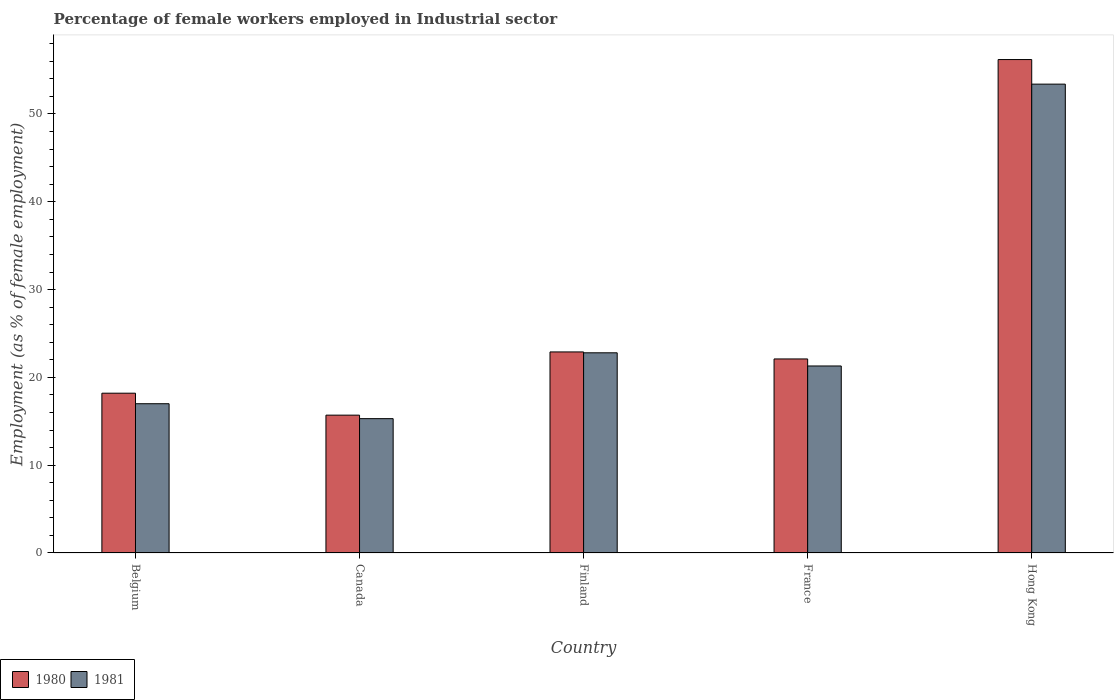How many different coloured bars are there?
Your answer should be very brief. 2. Are the number of bars per tick equal to the number of legend labels?
Give a very brief answer. Yes. How many bars are there on the 4th tick from the right?
Provide a succinct answer. 2. What is the label of the 5th group of bars from the left?
Provide a succinct answer. Hong Kong. In how many cases, is the number of bars for a given country not equal to the number of legend labels?
Give a very brief answer. 0. What is the percentage of females employed in Industrial sector in 1981 in France?
Offer a terse response. 21.3. Across all countries, what is the maximum percentage of females employed in Industrial sector in 1980?
Provide a succinct answer. 56.2. Across all countries, what is the minimum percentage of females employed in Industrial sector in 1980?
Give a very brief answer. 15.7. In which country was the percentage of females employed in Industrial sector in 1981 maximum?
Make the answer very short. Hong Kong. In which country was the percentage of females employed in Industrial sector in 1981 minimum?
Your response must be concise. Canada. What is the total percentage of females employed in Industrial sector in 1980 in the graph?
Your answer should be very brief. 135.1. What is the difference between the percentage of females employed in Industrial sector in 1980 in Belgium and that in Finland?
Offer a terse response. -4.7. What is the difference between the percentage of females employed in Industrial sector in 1980 in France and the percentage of females employed in Industrial sector in 1981 in Finland?
Offer a very short reply. -0.7. What is the average percentage of females employed in Industrial sector in 1981 per country?
Give a very brief answer. 25.96. What is the difference between the percentage of females employed in Industrial sector of/in 1981 and percentage of females employed in Industrial sector of/in 1980 in Finland?
Your answer should be compact. -0.1. In how many countries, is the percentage of females employed in Industrial sector in 1981 greater than 40 %?
Give a very brief answer. 1. What is the ratio of the percentage of females employed in Industrial sector in 1981 in Canada to that in France?
Keep it short and to the point. 0.72. What is the difference between the highest and the second highest percentage of females employed in Industrial sector in 1981?
Give a very brief answer. -32.1. What is the difference between the highest and the lowest percentage of females employed in Industrial sector in 1980?
Give a very brief answer. 40.5. What does the 1st bar from the left in Hong Kong represents?
Keep it short and to the point. 1980. What does the 2nd bar from the right in France represents?
Your answer should be very brief. 1980. Are all the bars in the graph horizontal?
Your answer should be compact. No. What is the difference between two consecutive major ticks on the Y-axis?
Your answer should be compact. 10. Does the graph contain any zero values?
Make the answer very short. No. Where does the legend appear in the graph?
Give a very brief answer. Bottom left. What is the title of the graph?
Offer a terse response. Percentage of female workers employed in Industrial sector. What is the label or title of the Y-axis?
Your response must be concise. Employment (as % of female employment). What is the Employment (as % of female employment) in 1980 in Belgium?
Keep it short and to the point. 18.2. What is the Employment (as % of female employment) of 1980 in Canada?
Offer a very short reply. 15.7. What is the Employment (as % of female employment) in 1981 in Canada?
Ensure brevity in your answer.  15.3. What is the Employment (as % of female employment) of 1980 in Finland?
Make the answer very short. 22.9. What is the Employment (as % of female employment) of 1981 in Finland?
Keep it short and to the point. 22.8. What is the Employment (as % of female employment) of 1980 in France?
Your response must be concise. 22.1. What is the Employment (as % of female employment) of 1981 in France?
Give a very brief answer. 21.3. What is the Employment (as % of female employment) of 1980 in Hong Kong?
Offer a terse response. 56.2. What is the Employment (as % of female employment) of 1981 in Hong Kong?
Make the answer very short. 53.4. Across all countries, what is the maximum Employment (as % of female employment) of 1980?
Give a very brief answer. 56.2. Across all countries, what is the maximum Employment (as % of female employment) in 1981?
Your answer should be compact. 53.4. Across all countries, what is the minimum Employment (as % of female employment) in 1980?
Give a very brief answer. 15.7. Across all countries, what is the minimum Employment (as % of female employment) in 1981?
Ensure brevity in your answer.  15.3. What is the total Employment (as % of female employment) of 1980 in the graph?
Your answer should be very brief. 135.1. What is the total Employment (as % of female employment) of 1981 in the graph?
Your response must be concise. 129.8. What is the difference between the Employment (as % of female employment) in 1980 in Belgium and that in Canada?
Provide a succinct answer. 2.5. What is the difference between the Employment (as % of female employment) in 1981 in Belgium and that in Canada?
Your answer should be compact. 1.7. What is the difference between the Employment (as % of female employment) of 1980 in Belgium and that in Finland?
Give a very brief answer. -4.7. What is the difference between the Employment (as % of female employment) of 1980 in Belgium and that in France?
Your answer should be compact. -3.9. What is the difference between the Employment (as % of female employment) in 1980 in Belgium and that in Hong Kong?
Your response must be concise. -38. What is the difference between the Employment (as % of female employment) of 1981 in Belgium and that in Hong Kong?
Keep it short and to the point. -36.4. What is the difference between the Employment (as % of female employment) of 1980 in Canada and that in France?
Give a very brief answer. -6.4. What is the difference between the Employment (as % of female employment) of 1981 in Canada and that in France?
Make the answer very short. -6. What is the difference between the Employment (as % of female employment) in 1980 in Canada and that in Hong Kong?
Make the answer very short. -40.5. What is the difference between the Employment (as % of female employment) of 1981 in Canada and that in Hong Kong?
Ensure brevity in your answer.  -38.1. What is the difference between the Employment (as % of female employment) in 1980 in Finland and that in Hong Kong?
Ensure brevity in your answer.  -33.3. What is the difference between the Employment (as % of female employment) in 1981 in Finland and that in Hong Kong?
Your answer should be very brief. -30.6. What is the difference between the Employment (as % of female employment) of 1980 in France and that in Hong Kong?
Offer a terse response. -34.1. What is the difference between the Employment (as % of female employment) of 1981 in France and that in Hong Kong?
Give a very brief answer. -32.1. What is the difference between the Employment (as % of female employment) in 1980 in Belgium and the Employment (as % of female employment) in 1981 in Canada?
Make the answer very short. 2.9. What is the difference between the Employment (as % of female employment) of 1980 in Belgium and the Employment (as % of female employment) of 1981 in Finland?
Provide a succinct answer. -4.6. What is the difference between the Employment (as % of female employment) of 1980 in Belgium and the Employment (as % of female employment) of 1981 in Hong Kong?
Ensure brevity in your answer.  -35.2. What is the difference between the Employment (as % of female employment) of 1980 in Canada and the Employment (as % of female employment) of 1981 in Finland?
Your answer should be compact. -7.1. What is the difference between the Employment (as % of female employment) in 1980 in Canada and the Employment (as % of female employment) in 1981 in Hong Kong?
Make the answer very short. -37.7. What is the difference between the Employment (as % of female employment) in 1980 in Finland and the Employment (as % of female employment) in 1981 in France?
Your answer should be compact. 1.6. What is the difference between the Employment (as % of female employment) in 1980 in Finland and the Employment (as % of female employment) in 1981 in Hong Kong?
Make the answer very short. -30.5. What is the difference between the Employment (as % of female employment) in 1980 in France and the Employment (as % of female employment) in 1981 in Hong Kong?
Keep it short and to the point. -31.3. What is the average Employment (as % of female employment) in 1980 per country?
Your response must be concise. 27.02. What is the average Employment (as % of female employment) in 1981 per country?
Offer a very short reply. 25.96. What is the difference between the Employment (as % of female employment) of 1980 and Employment (as % of female employment) of 1981 in Finland?
Keep it short and to the point. 0.1. What is the difference between the Employment (as % of female employment) of 1980 and Employment (as % of female employment) of 1981 in France?
Offer a very short reply. 0.8. What is the ratio of the Employment (as % of female employment) of 1980 in Belgium to that in Canada?
Give a very brief answer. 1.16. What is the ratio of the Employment (as % of female employment) of 1980 in Belgium to that in Finland?
Offer a very short reply. 0.79. What is the ratio of the Employment (as % of female employment) of 1981 in Belgium to that in Finland?
Your response must be concise. 0.75. What is the ratio of the Employment (as % of female employment) of 1980 in Belgium to that in France?
Offer a very short reply. 0.82. What is the ratio of the Employment (as % of female employment) in 1981 in Belgium to that in France?
Offer a terse response. 0.8. What is the ratio of the Employment (as % of female employment) of 1980 in Belgium to that in Hong Kong?
Your response must be concise. 0.32. What is the ratio of the Employment (as % of female employment) of 1981 in Belgium to that in Hong Kong?
Provide a short and direct response. 0.32. What is the ratio of the Employment (as % of female employment) in 1980 in Canada to that in Finland?
Provide a short and direct response. 0.69. What is the ratio of the Employment (as % of female employment) of 1981 in Canada to that in Finland?
Your response must be concise. 0.67. What is the ratio of the Employment (as % of female employment) in 1980 in Canada to that in France?
Your answer should be compact. 0.71. What is the ratio of the Employment (as % of female employment) in 1981 in Canada to that in France?
Give a very brief answer. 0.72. What is the ratio of the Employment (as % of female employment) of 1980 in Canada to that in Hong Kong?
Offer a terse response. 0.28. What is the ratio of the Employment (as % of female employment) in 1981 in Canada to that in Hong Kong?
Your answer should be very brief. 0.29. What is the ratio of the Employment (as % of female employment) in 1980 in Finland to that in France?
Your answer should be very brief. 1.04. What is the ratio of the Employment (as % of female employment) in 1981 in Finland to that in France?
Keep it short and to the point. 1.07. What is the ratio of the Employment (as % of female employment) of 1980 in Finland to that in Hong Kong?
Offer a terse response. 0.41. What is the ratio of the Employment (as % of female employment) of 1981 in Finland to that in Hong Kong?
Offer a terse response. 0.43. What is the ratio of the Employment (as % of female employment) of 1980 in France to that in Hong Kong?
Make the answer very short. 0.39. What is the ratio of the Employment (as % of female employment) in 1981 in France to that in Hong Kong?
Offer a terse response. 0.4. What is the difference between the highest and the second highest Employment (as % of female employment) of 1980?
Your answer should be compact. 33.3. What is the difference between the highest and the second highest Employment (as % of female employment) in 1981?
Keep it short and to the point. 30.6. What is the difference between the highest and the lowest Employment (as % of female employment) in 1980?
Ensure brevity in your answer.  40.5. What is the difference between the highest and the lowest Employment (as % of female employment) of 1981?
Make the answer very short. 38.1. 